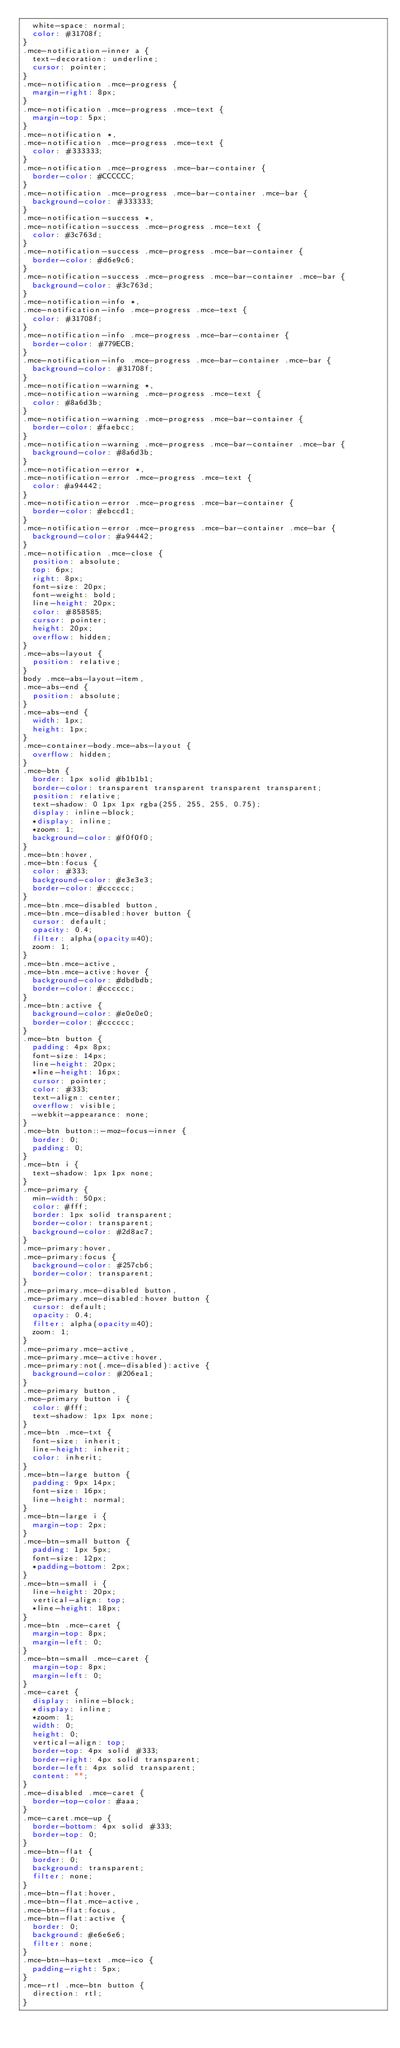Convert code to text. <code><loc_0><loc_0><loc_500><loc_500><_CSS_>  white-space: normal;
  color: #31708f;
}
.mce-notification-inner a {
  text-decoration: underline;
  cursor: pointer;
}
.mce-notification .mce-progress {
  margin-right: 8px;
}
.mce-notification .mce-progress .mce-text {
  margin-top: 5px;
}
.mce-notification *,
.mce-notification .mce-progress .mce-text {
  color: #333333;
}
.mce-notification .mce-progress .mce-bar-container {
  border-color: #CCCCCC;
}
.mce-notification .mce-progress .mce-bar-container .mce-bar {
  background-color: #333333;
}
.mce-notification-success *,
.mce-notification-success .mce-progress .mce-text {
  color: #3c763d;
}
.mce-notification-success .mce-progress .mce-bar-container {
  border-color: #d6e9c6;
}
.mce-notification-success .mce-progress .mce-bar-container .mce-bar {
  background-color: #3c763d;
}
.mce-notification-info *,
.mce-notification-info .mce-progress .mce-text {
  color: #31708f;
}
.mce-notification-info .mce-progress .mce-bar-container {
  border-color: #779ECB;
}
.mce-notification-info .mce-progress .mce-bar-container .mce-bar {
  background-color: #31708f;
}
.mce-notification-warning *,
.mce-notification-warning .mce-progress .mce-text {
  color: #8a6d3b;
}
.mce-notification-warning .mce-progress .mce-bar-container {
  border-color: #faebcc;
}
.mce-notification-warning .mce-progress .mce-bar-container .mce-bar {
  background-color: #8a6d3b;
}
.mce-notification-error *,
.mce-notification-error .mce-progress .mce-text {
  color: #a94442;
}
.mce-notification-error .mce-progress .mce-bar-container {
  border-color: #ebccd1;
}
.mce-notification-error .mce-progress .mce-bar-container .mce-bar {
  background-color: #a94442;
}
.mce-notification .mce-close {
  position: absolute;
  top: 6px;
  right: 8px;
  font-size: 20px;
  font-weight: bold;
  line-height: 20px;
  color: #858585;
  cursor: pointer;
  height: 20px;
  overflow: hidden;
}
.mce-abs-layout {
  position: relative;
}
body .mce-abs-layout-item,
.mce-abs-end {
  position: absolute;
}
.mce-abs-end {
  width: 1px;
  height: 1px;
}
.mce-container-body.mce-abs-layout {
  overflow: hidden;
}
.mce-btn {
  border: 1px solid #b1b1b1;
  border-color: transparent transparent transparent transparent;
  position: relative;
  text-shadow: 0 1px 1px rgba(255, 255, 255, 0.75);
  display: inline-block;
  *display: inline;
  *zoom: 1;
  background-color: #f0f0f0;
}
.mce-btn:hover,
.mce-btn:focus {
  color: #333;
  background-color: #e3e3e3;
  border-color: #cccccc;
}
.mce-btn.mce-disabled button,
.mce-btn.mce-disabled:hover button {
  cursor: default;
  opacity: 0.4;
  filter: alpha(opacity=40);
  zoom: 1;
}
.mce-btn.mce-active,
.mce-btn.mce-active:hover {
  background-color: #dbdbdb;
  border-color: #cccccc;
}
.mce-btn:active {
  background-color: #e0e0e0;
  border-color: #cccccc;
}
.mce-btn button {
  padding: 4px 8px;
  font-size: 14px;
  line-height: 20px;
  *line-height: 16px;
  cursor: pointer;
  color: #333;
  text-align: center;
  overflow: visible;
  -webkit-appearance: none;
}
.mce-btn button::-moz-focus-inner {
  border: 0;
  padding: 0;
}
.mce-btn i {
  text-shadow: 1px 1px none;
}
.mce-primary {
  min-width: 50px;
  color: #fff;
  border: 1px solid transparent;
  border-color: transparent;
  background-color: #2d8ac7;
}
.mce-primary:hover,
.mce-primary:focus {
  background-color: #257cb6;
  border-color: transparent;
}
.mce-primary.mce-disabled button,
.mce-primary.mce-disabled:hover button {
  cursor: default;
  opacity: 0.4;
  filter: alpha(opacity=40);
  zoom: 1;
}
.mce-primary.mce-active,
.mce-primary.mce-active:hover,
.mce-primary:not(.mce-disabled):active {
  background-color: #206ea1;
}
.mce-primary button,
.mce-primary button i {
  color: #fff;
  text-shadow: 1px 1px none;
}
.mce-btn .mce-txt {
  font-size: inherit;
  line-height: inherit;
  color: inherit;
}
.mce-btn-large button {
  padding: 9px 14px;
  font-size: 16px;
  line-height: normal;
}
.mce-btn-large i {
  margin-top: 2px;
}
.mce-btn-small button {
  padding: 1px 5px;
  font-size: 12px;
  *padding-bottom: 2px;
}
.mce-btn-small i {
  line-height: 20px;
  vertical-align: top;
  *line-height: 18px;
}
.mce-btn .mce-caret {
  margin-top: 8px;
  margin-left: 0;
}
.mce-btn-small .mce-caret {
  margin-top: 8px;
  margin-left: 0;
}
.mce-caret {
  display: inline-block;
  *display: inline;
  *zoom: 1;
  width: 0;
  height: 0;
  vertical-align: top;
  border-top: 4px solid #333;
  border-right: 4px solid transparent;
  border-left: 4px solid transparent;
  content: "";
}
.mce-disabled .mce-caret {
  border-top-color: #aaa;
}
.mce-caret.mce-up {
  border-bottom: 4px solid #333;
  border-top: 0;
}
.mce-btn-flat {
  border: 0;
  background: transparent;
  filter: none;
}
.mce-btn-flat:hover,
.mce-btn-flat.mce-active,
.mce-btn-flat:focus,
.mce-btn-flat:active {
  border: 0;
  background: #e6e6e6;
  filter: none;
}
.mce-btn-has-text .mce-ico {
  padding-right: 5px;
}
.mce-rtl .mce-btn button {
  direction: rtl;
}</code> 